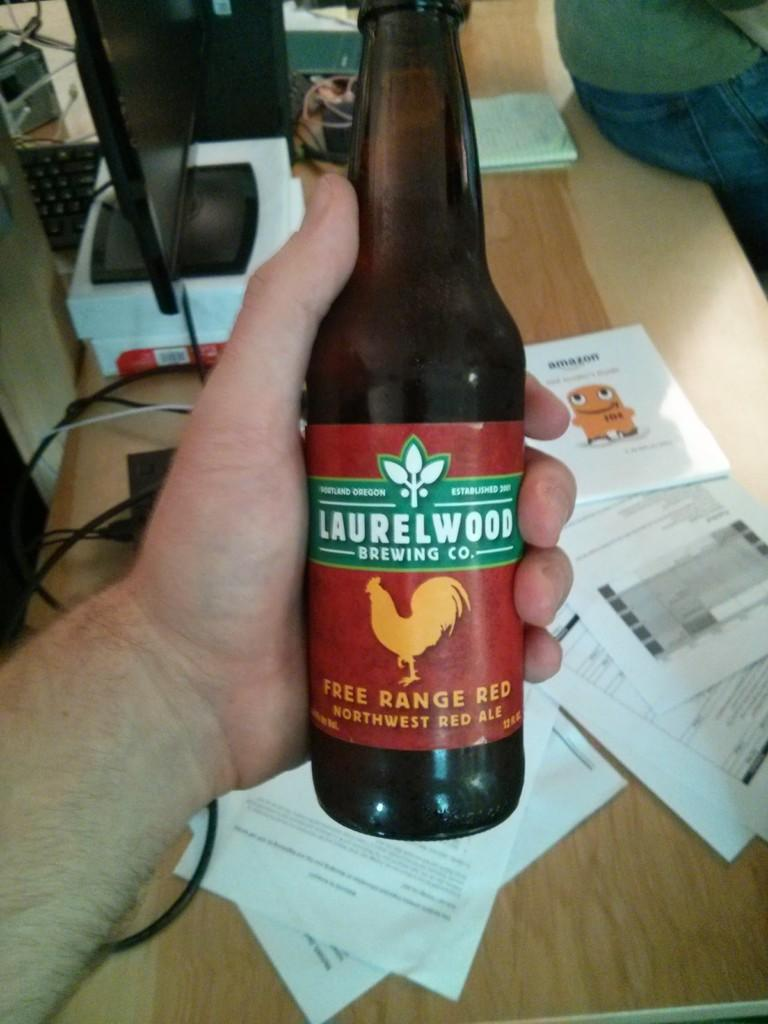<image>
Offer a succinct explanation of the picture presented. Someone holding a bottle of Laurelwood Southwest Red Ale. 